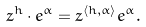<formula> <loc_0><loc_0><loc_500><loc_500>z ^ { h } \cdot e ^ { \alpha } = z ^ { \langle h , \alpha \rangle } e ^ { \alpha } .</formula> 